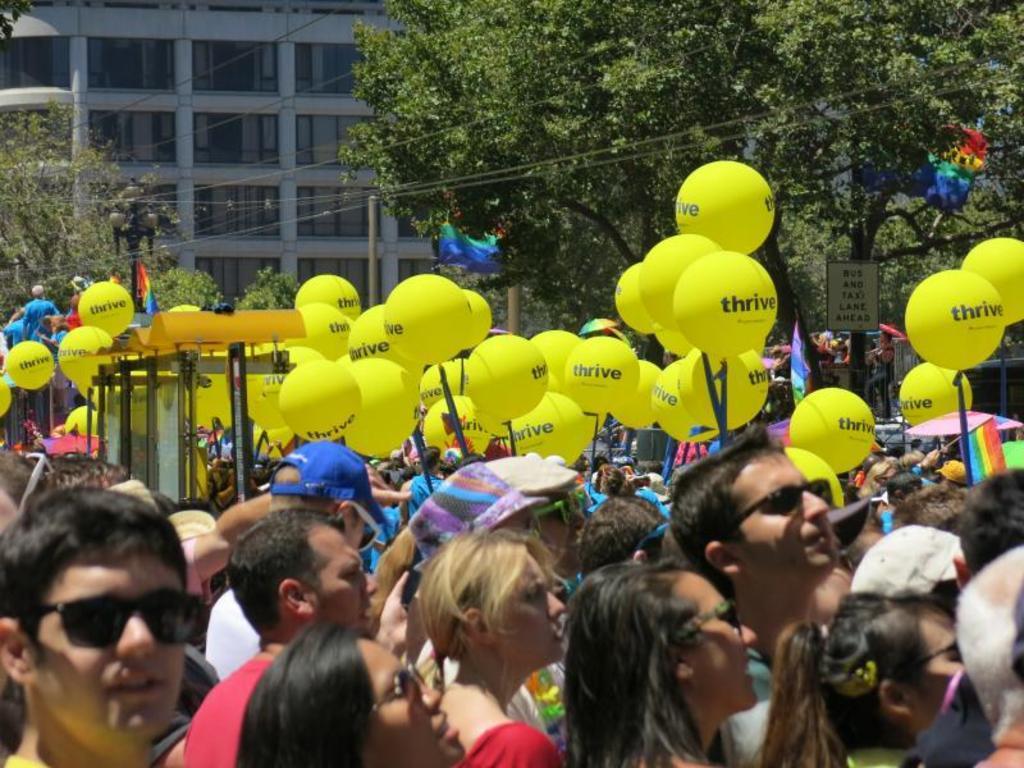In one or two sentences, can you explain what this image depicts? In the picture we can see a public stand on the and holding the balloons which are light yellow in color and written on it as thrive and in the background, we can see some poles, trees and a building with glasses to it. 